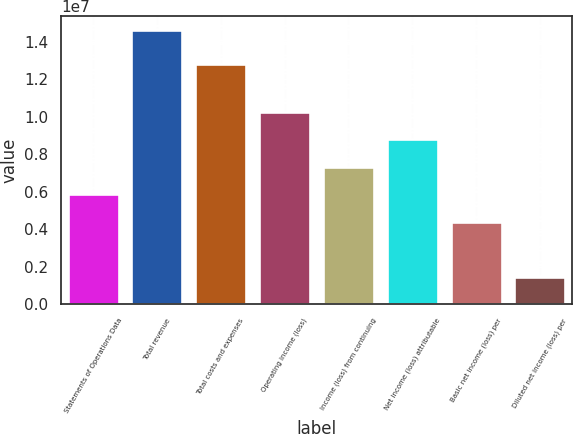Convert chart. <chart><loc_0><loc_0><loc_500><loc_500><bar_chart><fcel>Statements of Operations Data<fcel>Total revenue<fcel>Total costs and expenses<fcel>Operating income (loss)<fcel>Income (loss) from continuing<fcel>Net income (loss) attributable<fcel>Basic net income (loss) per<fcel>Diluted net income (loss) per<nl><fcel>5.85736e+06<fcel>1.46434e+07<fcel>1.28189e+07<fcel>1.02504e+07<fcel>7.32169e+06<fcel>8.78603e+06<fcel>4.39302e+06<fcel>1.46434e+06<nl></chart> 